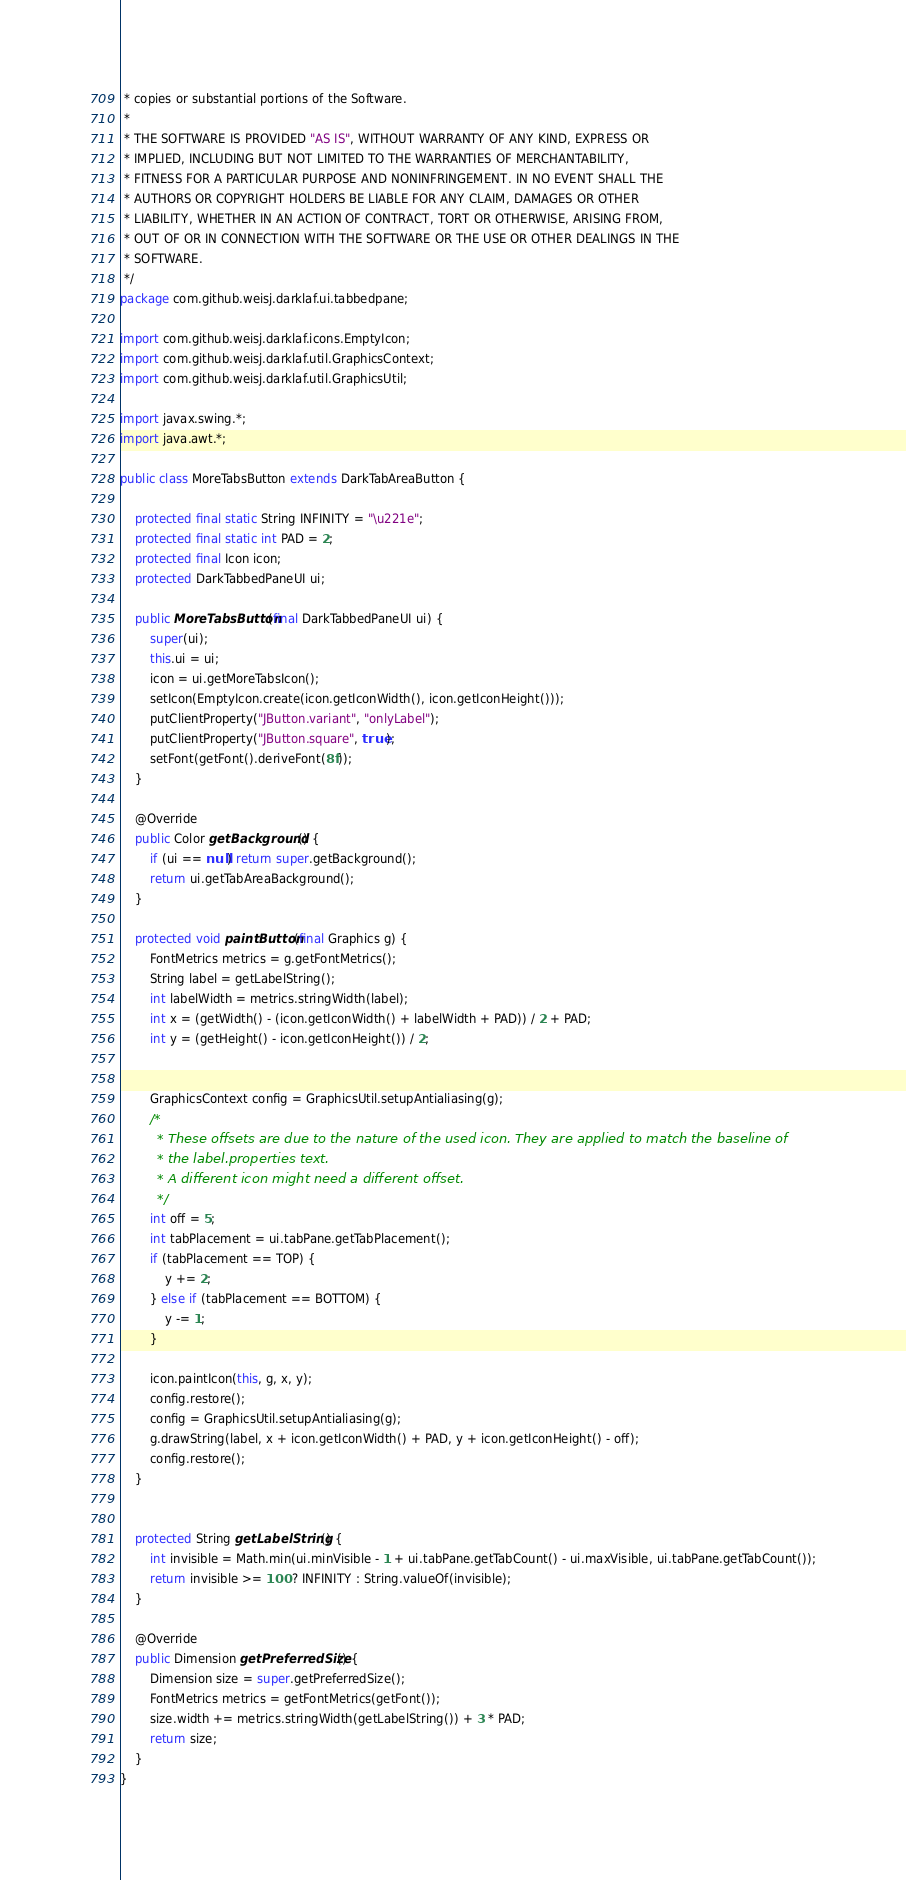Convert code to text. <code><loc_0><loc_0><loc_500><loc_500><_Java_> * copies or substantial portions of the Software.
 *
 * THE SOFTWARE IS PROVIDED "AS IS", WITHOUT WARRANTY OF ANY KIND, EXPRESS OR
 * IMPLIED, INCLUDING BUT NOT LIMITED TO THE WARRANTIES OF MERCHANTABILITY,
 * FITNESS FOR A PARTICULAR PURPOSE AND NONINFRINGEMENT. IN NO EVENT SHALL THE
 * AUTHORS OR COPYRIGHT HOLDERS BE LIABLE FOR ANY CLAIM, DAMAGES OR OTHER
 * LIABILITY, WHETHER IN AN ACTION OF CONTRACT, TORT OR OTHERWISE, ARISING FROM,
 * OUT OF OR IN CONNECTION WITH THE SOFTWARE OR THE USE OR OTHER DEALINGS IN THE
 * SOFTWARE.
 */
package com.github.weisj.darklaf.ui.tabbedpane;

import com.github.weisj.darklaf.icons.EmptyIcon;
import com.github.weisj.darklaf.util.GraphicsContext;
import com.github.weisj.darklaf.util.GraphicsUtil;

import javax.swing.*;
import java.awt.*;

public class MoreTabsButton extends DarkTabAreaButton {

    protected final static String INFINITY = "\u221e";
    protected final static int PAD = 2;
    protected final Icon icon;
    protected DarkTabbedPaneUI ui;

    public MoreTabsButton(final DarkTabbedPaneUI ui) {
        super(ui);
        this.ui = ui;
        icon = ui.getMoreTabsIcon();
        setIcon(EmptyIcon.create(icon.getIconWidth(), icon.getIconHeight()));
        putClientProperty("JButton.variant", "onlyLabel");
        putClientProperty("JButton.square", true);
        setFont(getFont().deriveFont(8f));
    }

    @Override
    public Color getBackground() {
        if (ui == null) return super.getBackground();
        return ui.getTabAreaBackground();
    }

    protected void paintButton(final Graphics g) {
        FontMetrics metrics = g.getFontMetrics();
        String label = getLabelString();
        int labelWidth = metrics.stringWidth(label);
        int x = (getWidth() - (icon.getIconWidth() + labelWidth + PAD)) / 2 + PAD;
        int y = (getHeight() - icon.getIconHeight()) / 2;


        GraphicsContext config = GraphicsUtil.setupAntialiasing(g);
        /*
         * These offsets are due to the nature of the used icon. They are applied to match the baseline of
         * the label.properties text.
         * A different icon might need a different offset.
         */
        int off = 5;
        int tabPlacement = ui.tabPane.getTabPlacement();
        if (tabPlacement == TOP) {
            y += 2;
        } else if (tabPlacement == BOTTOM) {
            y -= 1;
        }

        icon.paintIcon(this, g, x, y);
        config.restore();
        config = GraphicsUtil.setupAntialiasing(g);
        g.drawString(label, x + icon.getIconWidth() + PAD, y + icon.getIconHeight() - off);
        config.restore();
    }


    protected String getLabelString() {
        int invisible = Math.min(ui.minVisible - 1 + ui.tabPane.getTabCount() - ui.maxVisible, ui.tabPane.getTabCount());
        return invisible >= 100 ? INFINITY : String.valueOf(invisible);
    }

    @Override
    public Dimension getPreferredSize() {
        Dimension size = super.getPreferredSize();
        FontMetrics metrics = getFontMetrics(getFont());
        size.width += metrics.stringWidth(getLabelString()) + 3 * PAD;
        return size;
    }
}
</code> 